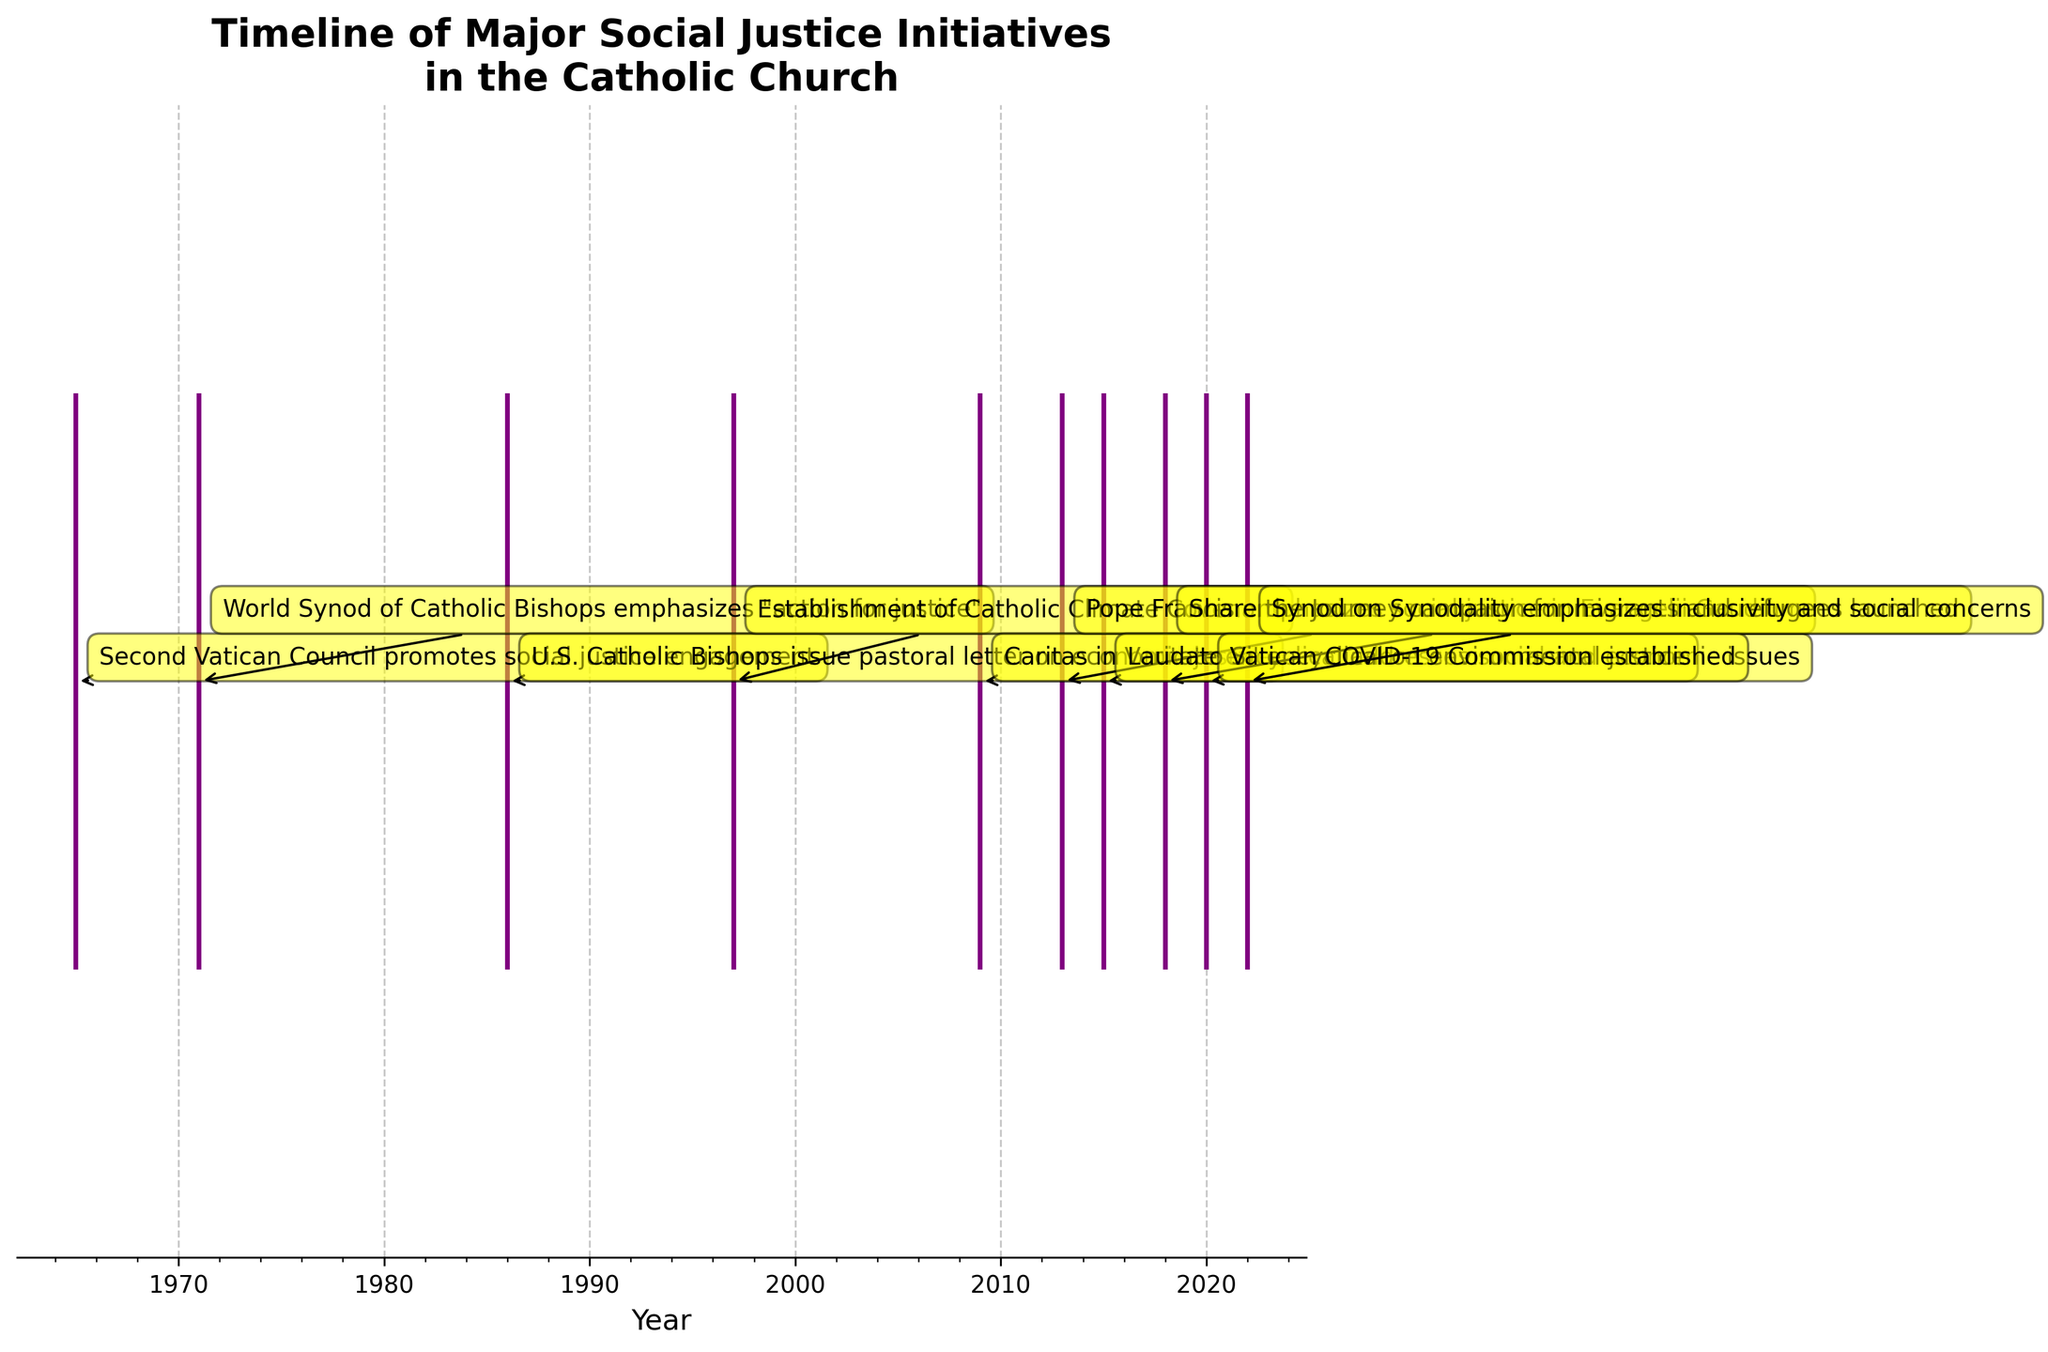What is the title of the figure? The title of the figure can usually be found at the top of the plot, written in a larger or bold typeface. In this figure, it is "Timeline of Major Social Justice Initiatives in the Catholic Church".
Answer: Timeline of Major Social Justice Initiatives in the Catholic Church What color are the event lines in the figure? The color of the event lines can be identified by observing the lines plotted on the x-axis. They are all consistently colored. Here, the event lines are purple.
Answer: Purple How many major policy changes related to social justice initiatives were there before 2000? To answer this, count the number of events listed in the timeline before the year 2000. The events are: 1965, 1971, 1986, and 1997, making a total of four events.
Answer: 4 In which year was the "Laudato Si' encyclical on environmental justice" published? Locate the event labeled "Laudato Si' encyclical on environmental justice" along the timeline, which points to the year 2015.
Answer: 2015 Which event occurred first among "Pope Francis emphasizes social justice in Evangelii Gaudium" and "Caritas in Veritate encyclical addresses social and economic issues"? Compare their years on the x-axis; "Caritas in Veritate encyclical addresses social and economic issues" (2009) occurred before "Pope Francis emphasizes social justice in Evangelii Gaudium" (2013).
Answer: Caritas in Veritate encyclical addresses social and economic issues What is the most recent major policy change related to social justice initiatives in the timeline? Find the latest year on the x-axis and identify the event associated with it. The event in the year 2022 is "Synod on Synodality emphasizes inclusivity and social concerns".
Answer: Synod on Synodality emphasizes inclusivity and social concerns How many years passed between the Second Vatican Council and the U.S. Catholic Bishops issuing the pastoral letter on economic justice? Compute the difference in years between 1986 (when the pastoral letter was issued) and 1965 (when the Second Vatican Council promoted social justice engagement). 1986 - 1965 = 21 years.
Answer: 21 years Which occurred closer in time, the "Establishment of Catholic Climate Covenant" and "Caritas in Veritate encyclical", or "The Synod on Synodality" and "Vatican COVID-19 Commission"? Calculate the differences: for the first pair, 2009 - 1997 = 12 years; for the second pair, 2022 - 2020 = 2 years. The second pair is closer in time.
Answer: The Synod on Synodality and Vatican COVID-19 Commission How frequently were major social justice policy changes introduced within the Catholic Church from 2015 to 2022? Identify the events within this time range: 2015, 2018, 2020, and 2022. Count the occurrences (4 events) and the number of years covered (2022 - 2015 = 7 years). The frequency is 4/7 ≈ 0.57 events per year on average.
Answer: Approximately 0.57 events per year What was the duration of the gap between any two consecutive policy changes in the 20th century that was the longest? The relevant years within the 20th century are 1965, 1971, 1986, and 1997. Calculate the gaps: 1971-1965 = 6 years, 1986-1971 = 15 years, 1997-1986 = 11 years. The largest gap is 15 years.
Answer: 15 years 